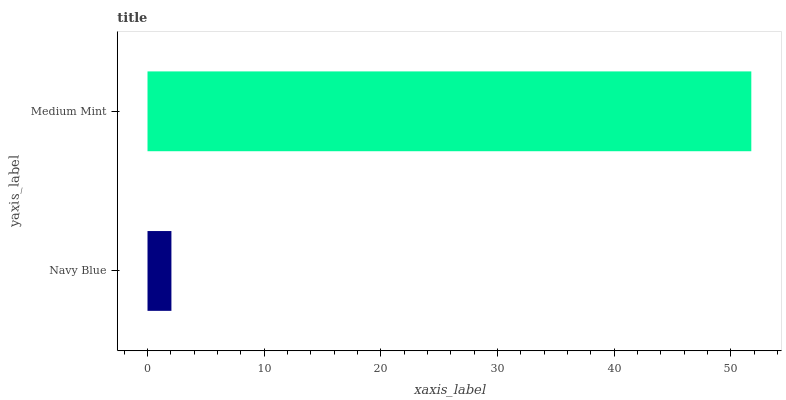Is Navy Blue the minimum?
Answer yes or no. Yes. Is Medium Mint the maximum?
Answer yes or no. Yes. Is Medium Mint the minimum?
Answer yes or no. No. Is Medium Mint greater than Navy Blue?
Answer yes or no. Yes. Is Navy Blue less than Medium Mint?
Answer yes or no. Yes. Is Navy Blue greater than Medium Mint?
Answer yes or no. No. Is Medium Mint less than Navy Blue?
Answer yes or no. No. Is Medium Mint the high median?
Answer yes or no. Yes. Is Navy Blue the low median?
Answer yes or no. Yes. Is Navy Blue the high median?
Answer yes or no. No. Is Medium Mint the low median?
Answer yes or no. No. 